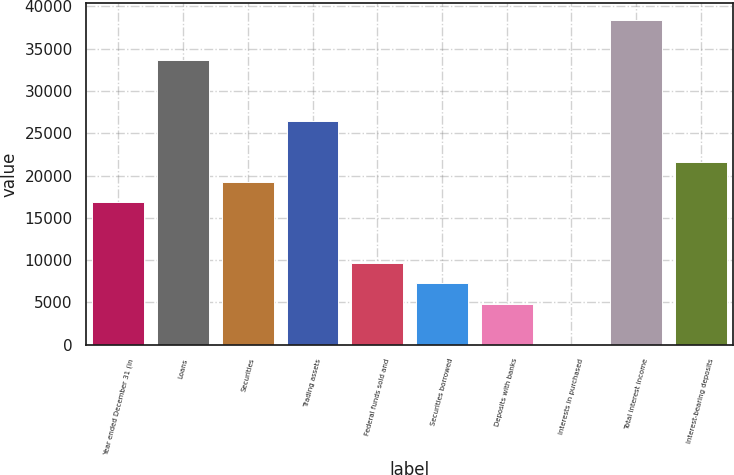Convert chart. <chart><loc_0><loc_0><loc_500><loc_500><bar_chart><fcel>Year ended December 31 (in<fcel>Loans<fcel>Securities<fcel>Trading assets<fcel>Federal funds sold and<fcel>Securities borrowed<fcel>Deposits with banks<fcel>Interests in purchased<fcel>Total interest income<fcel>Interest-bearing deposits<nl><fcel>16850<fcel>33636<fcel>19248<fcel>26442<fcel>9656<fcel>7258<fcel>4860<fcel>64<fcel>38432<fcel>21646<nl></chart> 